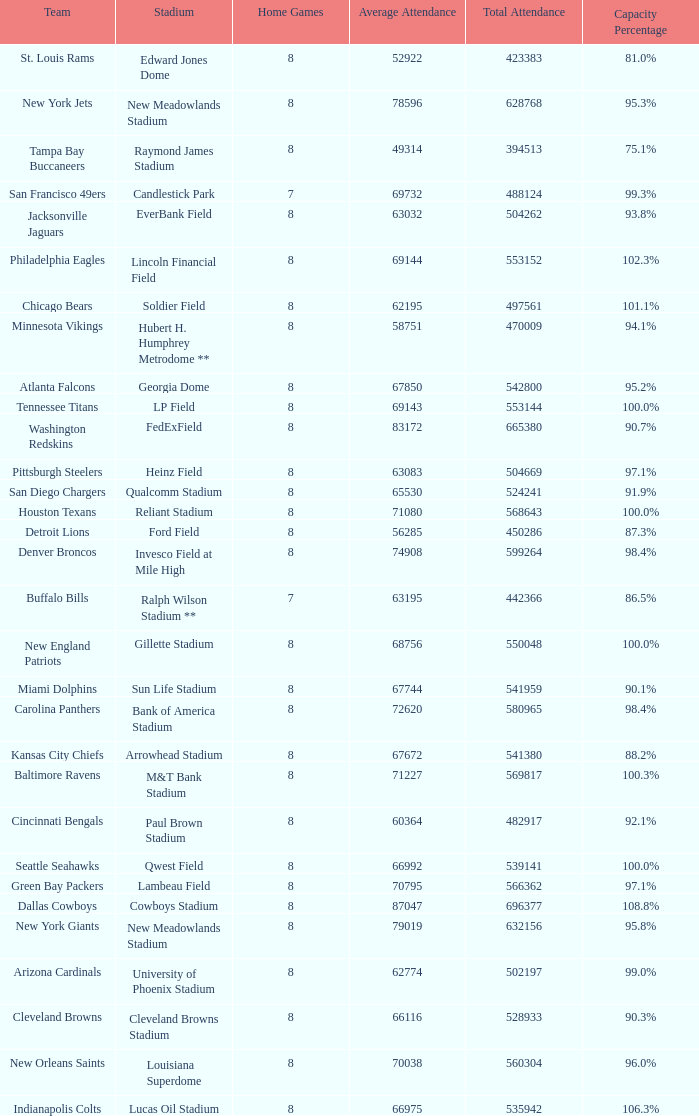What was the total attendance of the New York Giants? 632156.0. 